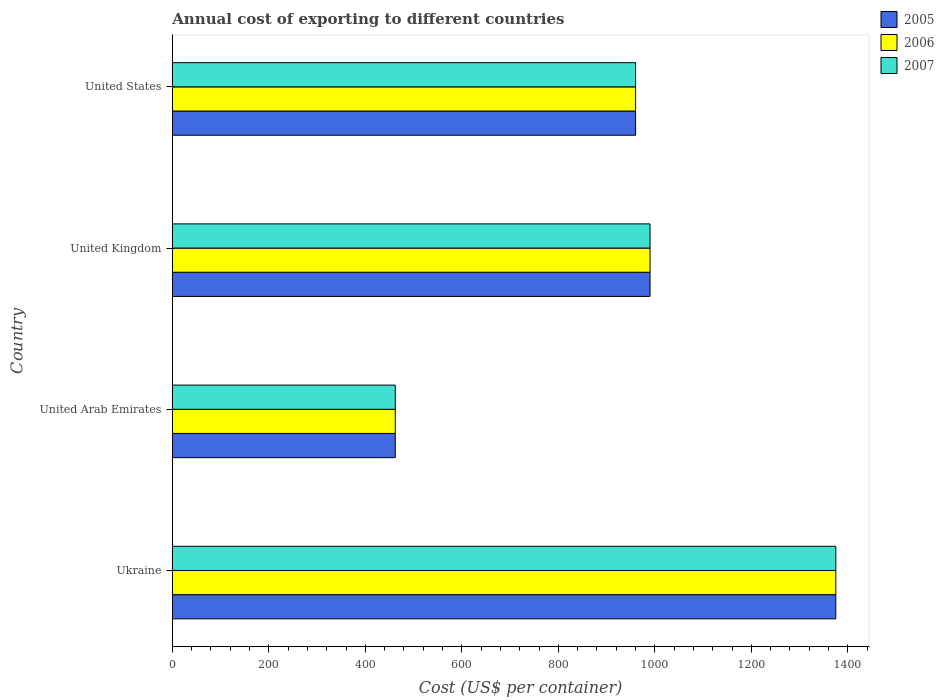How many groups of bars are there?
Provide a short and direct response. 4. Are the number of bars per tick equal to the number of legend labels?
Offer a terse response. Yes. What is the label of the 2nd group of bars from the top?
Ensure brevity in your answer.  United Kingdom. What is the total annual cost of exporting in 2005 in United States?
Your answer should be very brief. 960. Across all countries, what is the maximum total annual cost of exporting in 2007?
Offer a very short reply. 1375. Across all countries, what is the minimum total annual cost of exporting in 2005?
Ensure brevity in your answer.  462. In which country was the total annual cost of exporting in 2006 maximum?
Ensure brevity in your answer.  Ukraine. In which country was the total annual cost of exporting in 2005 minimum?
Ensure brevity in your answer.  United Arab Emirates. What is the total total annual cost of exporting in 2006 in the graph?
Keep it short and to the point. 3787. What is the difference between the total annual cost of exporting in 2007 in United Arab Emirates and that in United States?
Give a very brief answer. -498. What is the difference between the total annual cost of exporting in 2005 in United Kingdom and the total annual cost of exporting in 2006 in United States?
Ensure brevity in your answer.  30. What is the average total annual cost of exporting in 2007 per country?
Your answer should be very brief. 946.75. What is the ratio of the total annual cost of exporting in 2006 in United Kingdom to that in United States?
Make the answer very short. 1.03. Is the total annual cost of exporting in 2006 in Ukraine less than that in United Kingdom?
Offer a very short reply. No. Is the difference between the total annual cost of exporting in 2005 in United Arab Emirates and United States greater than the difference between the total annual cost of exporting in 2007 in United Arab Emirates and United States?
Give a very brief answer. No. What is the difference between the highest and the second highest total annual cost of exporting in 2005?
Give a very brief answer. 385. What is the difference between the highest and the lowest total annual cost of exporting in 2005?
Provide a short and direct response. 913. Is it the case that in every country, the sum of the total annual cost of exporting in 2005 and total annual cost of exporting in 2007 is greater than the total annual cost of exporting in 2006?
Offer a terse response. Yes. Are all the bars in the graph horizontal?
Keep it short and to the point. Yes. What is the difference between two consecutive major ticks on the X-axis?
Make the answer very short. 200. Are the values on the major ticks of X-axis written in scientific E-notation?
Your answer should be compact. No. Does the graph contain any zero values?
Your answer should be very brief. No. How many legend labels are there?
Provide a short and direct response. 3. What is the title of the graph?
Provide a succinct answer. Annual cost of exporting to different countries. Does "2003" appear as one of the legend labels in the graph?
Provide a succinct answer. No. What is the label or title of the X-axis?
Ensure brevity in your answer.  Cost (US$ per container). What is the label or title of the Y-axis?
Make the answer very short. Country. What is the Cost (US$ per container) of 2005 in Ukraine?
Provide a succinct answer. 1375. What is the Cost (US$ per container) in 2006 in Ukraine?
Make the answer very short. 1375. What is the Cost (US$ per container) of 2007 in Ukraine?
Give a very brief answer. 1375. What is the Cost (US$ per container) in 2005 in United Arab Emirates?
Provide a succinct answer. 462. What is the Cost (US$ per container) of 2006 in United Arab Emirates?
Ensure brevity in your answer.  462. What is the Cost (US$ per container) in 2007 in United Arab Emirates?
Your answer should be compact. 462. What is the Cost (US$ per container) in 2005 in United Kingdom?
Provide a short and direct response. 990. What is the Cost (US$ per container) of 2006 in United Kingdom?
Ensure brevity in your answer.  990. What is the Cost (US$ per container) of 2007 in United Kingdom?
Keep it short and to the point. 990. What is the Cost (US$ per container) in 2005 in United States?
Offer a very short reply. 960. What is the Cost (US$ per container) in 2006 in United States?
Keep it short and to the point. 960. What is the Cost (US$ per container) of 2007 in United States?
Make the answer very short. 960. Across all countries, what is the maximum Cost (US$ per container) in 2005?
Provide a succinct answer. 1375. Across all countries, what is the maximum Cost (US$ per container) of 2006?
Offer a terse response. 1375. Across all countries, what is the maximum Cost (US$ per container) in 2007?
Keep it short and to the point. 1375. Across all countries, what is the minimum Cost (US$ per container) in 2005?
Provide a short and direct response. 462. Across all countries, what is the minimum Cost (US$ per container) of 2006?
Your answer should be very brief. 462. Across all countries, what is the minimum Cost (US$ per container) in 2007?
Your response must be concise. 462. What is the total Cost (US$ per container) in 2005 in the graph?
Ensure brevity in your answer.  3787. What is the total Cost (US$ per container) of 2006 in the graph?
Provide a succinct answer. 3787. What is the total Cost (US$ per container) in 2007 in the graph?
Provide a short and direct response. 3787. What is the difference between the Cost (US$ per container) in 2005 in Ukraine and that in United Arab Emirates?
Your answer should be compact. 913. What is the difference between the Cost (US$ per container) in 2006 in Ukraine and that in United Arab Emirates?
Provide a short and direct response. 913. What is the difference between the Cost (US$ per container) in 2007 in Ukraine and that in United Arab Emirates?
Keep it short and to the point. 913. What is the difference between the Cost (US$ per container) of 2005 in Ukraine and that in United Kingdom?
Your response must be concise. 385. What is the difference between the Cost (US$ per container) of 2006 in Ukraine and that in United Kingdom?
Offer a very short reply. 385. What is the difference between the Cost (US$ per container) in 2007 in Ukraine and that in United Kingdom?
Provide a succinct answer. 385. What is the difference between the Cost (US$ per container) in 2005 in Ukraine and that in United States?
Give a very brief answer. 415. What is the difference between the Cost (US$ per container) in 2006 in Ukraine and that in United States?
Your response must be concise. 415. What is the difference between the Cost (US$ per container) of 2007 in Ukraine and that in United States?
Ensure brevity in your answer.  415. What is the difference between the Cost (US$ per container) of 2005 in United Arab Emirates and that in United Kingdom?
Offer a terse response. -528. What is the difference between the Cost (US$ per container) of 2006 in United Arab Emirates and that in United Kingdom?
Ensure brevity in your answer.  -528. What is the difference between the Cost (US$ per container) in 2007 in United Arab Emirates and that in United Kingdom?
Provide a succinct answer. -528. What is the difference between the Cost (US$ per container) of 2005 in United Arab Emirates and that in United States?
Ensure brevity in your answer.  -498. What is the difference between the Cost (US$ per container) in 2006 in United Arab Emirates and that in United States?
Provide a short and direct response. -498. What is the difference between the Cost (US$ per container) of 2007 in United Arab Emirates and that in United States?
Offer a terse response. -498. What is the difference between the Cost (US$ per container) in 2006 in United Kingdom and that in United States?
Provide a short and direct response. 30. What is the difference between the Cost (US$ per container) of 2007 in United Kingdom and that in United States?
Offer a terse response. 30. What is the difference between the Cost (US$ per container) in 2005 in Ukraine and the Cost (US$ per container) in 2006 in United Arab Emirates?
Provide a succinct answer. 913. What is the difference between the Cost (US$ per container) of 2005 in Ukraine and the Cost (US$ per container) of 2007 in United Arab Emirates?
Offer a terse response. 913. What is the difference between the Cost (US$ per container) of 2006 in Ukraine and the Cost (US$ per container) of 2007 in United Arab Emirates?
Ensure brevity in your answer.  913. What is the difference between the Cost (US$ per container) in 2005 in Ukraine and the Cost (US$ per container) in 2006 in United Kingdom?
Make the answer very short. 385. What is the difference between the Cost (US$ per container) in 2005 in Ukraine and the Cost (US$ per container) in 2007 in United Kingdom?
Provide a succinct answer. 385. What is the difference between the Cost (US$ per container) of 2006 in Ukraine and the Cost (US$ per container) of 2007 in United Kingdom?
Ensure brevity in your answer.  385. What is the difference between the Cost (US$ per container) in 2005 in Ukraine and the Cost (US$ per container) in 2006 in United States?
Keep it short and to the point. 415. What is the difference between the Cost (US$ per container) of 2005 in Ukraine and the Cost (US$ per container) of 2007 in United States?
Keep it short and to the point. 415. What is the difference between the Cost (US$ per container) in 2006 in Ukraine and the Cost (US$ per container) in 2007 in United States?
Offer a terse response. 415. What is the difference between the Cost (US$ per container) in 2005 in United Arab Emirates and the Cost (US$ per container) in 2006 in United Kingdom?
Your answer should be very brief. -528. What is the difference between the Cost (US$ per container) of 2005 in United Arab Emirates and the Cost (US$ per container) of 2007 in United Kingdom?
Your answer should be very brief. -528. What is the difference between the Cost (US$ per container) of 2006 in United Arab Emirates and the Cost (US$ per container) of 2007 in United Kingdom?
Your answer should be compact. -528. What is the difference between the Cost (US$ per container) in 2005 in United Arab Emirates and the Cost (US$ per container) in 2006 in United States?
Give a very brief answer. -498. What is the difference between the Cost (US$ per container) in 2005 in United Arab Emirates and the Cost (US$ per container) in 2007 in United States?
Offer a terse response. -498. What is the difference between the Cost (US$ per container) of 2006 in United Arab Emirates and the Cost (US$ per container) of 2007 in United States?
Keep it short and to the point. -498. What is the difference between the Cost (US$ per container) of 2006 in United Kingdom and the Cost (US$ per container) of 2007 in United States?
Offer a terse response. 30. What is the average Cost (US$ per container) in 2005 per country?
Your answer should be compact. 946.75. What is the average Cost (US$ per container) in 2006 per country?
Keep it short and to the point. 946.75. What is the average Cost (US$ per container) in 2007 per country?
Provide a short and direct response. 946.75. What is the difference between the Cost (US$ per container) of 2005 and Cost (US$ per container) of 2006 in United Arab Emirates?
Provide a short and direct response. 0. What is the difference between the Cost (US$ per container) in 2005 and Cost (US$ per container) in 2006 in United Kingdom?
Make the answer very short. 0. What is the difference between the Cost (US$ per container) of 2005 and Cost (US$ per container) of 2007 in United Kingdom?
Provide a succinct answer. 0. What is the difference between the Cost (US$ per container) in 2005 and Cost (US$ per container) in 2007 in United States?
Your response must be concise. 0. What is the difference between the Cost (US$ per container) in 2006 and Cost (US$ per container) in 2007 in United States?
Ensure brevity in your answer.  0. What is the ratio of the Cost (US$ per container) of 2005 in Ukraine to that in United Arab Emirates?
Provide a succinct answer. 2.98. What is the ratio of the Cost (US$ per container) in 2006 in Ukraine to that in United Arab Emirates?
Offer a very short reply. 2.98. What is the ratio of the Cost (US$ per container) in 2007 in Ukraine to that in United Arab Emirates?
Offer a very short reply. 2.98. What is the ratio of the Cost (US$ per container) in 2005 in Ukraine to that in United Kingdom?
Offer a terse response. 1.39. What is the ratio of the Cost (US$ per container) of 2006 in Ukraine to that in United Kingdom?
Give a very brief answer. 1.39. What is the ratio of the Cost (US$ per container) in 2007 in Ukraine to that in United Kingdom?
Ensure brevity in your answer.  1.39. What is the ratio of the Cost (US$ per container) in 2005 in Ukraine to that in United States?
Your response must be concise. 1.43. What is the ratio of the Cost (US$ per container) of 2006 in Ukraine to that in United States?
Ensure brevity in your answer.  1.43. What is the ratio of the Cost (US$ per container) in 2007 in Ukraine to that in United States?
Your answer should be very brief. 1.43. What is the ratio of the Cost (US$ per container) of 2005 in United Arab Emirates to that in United Kingdom?
Provide a succinct answer. 0.47. What is the ratio of the Cost (US$ per container) in 2006 in United Arab Emirates to that in United Kingdom?
Give a very brief answer. 0.47. What is the ratio of the Cost (US$ per container) in 2007 in United Arab Emirates to that in United Kingdom?
Offer a terse response. 0.47. What is the ratio of the Cost (US$ per container) in 2005 in United Arab Emirates to that in United States?
Ensure brevity in your answer.  0.48. What is the ratio of the Cost (US$ per container) of 2006 in United Arab Emirates to that in United States?
Make the answer very short. 0.48. What is the ratio of the Cost (US$ per container) of 2007 in United Arab Emirates to that in United States?
Make the answer very short. 0.48. What is the ratio of the Cost (US$ per container) of 2005 in United Kingdom to that in United States?
Offer a terse response. 1.03. What is the ratio of the Cost (US$ per container) of 2006 in United Kingdom to that in United States?
Ensure brevity in your answer.  1.03. What is the ratio of the Cost (US$ per container) of 2007 in United Kingdom to that in United States?
Offer a very short reply. 1.03. What is the difference between the highest and the second highest Cost (US$ per container) in 2005?
Your answer should be very brief. 385. What is the difference between the highest and the second highest Cost (US$ per container) of 2006?
Provide a succinct answer. 385. What is the difference between the highest and the second highest Cost (US$ per container) in 2007?
Your answer should be very brief. 385. What is the difference between the highest and the lowest Cost (US$ per container) of 2005?
Keep it short and to the point. 913. What is the difference between the highest and the lowest Cost (US$ per container) in 2006?
Your response must be concise. 913. What is the difference between the highest and the lowest Cost (US$ per container) in 2007?
Your response must be concise. 913. 